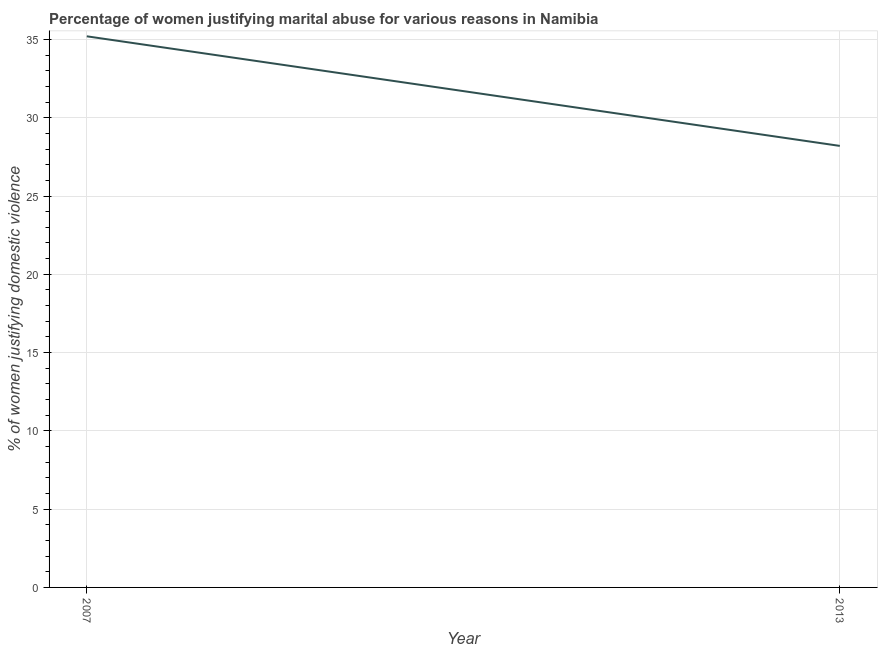What is the percentage of women justifying marital abuse in 2007?
Offer a very short reply. 35.2. Across all years, what is the maximum percentage of women justifying marital abuse?
Offer a very short reply. 35.2. Across all years, what is the minimum percentage of women justifying marital abuse?
Give a very brief answer. 28.2. In which year was the percentage of women justifying marital abuse maximum?
Provide a short and direct response. 2007. What is the sum of the percentage of women justifying marital abuse?
Your answer should be very brief. 63.4. What is the difference between the percentage of women justifying marital abuse in 2007 and 2013?
Make the answer very short. 7. What is the average percentage of women justifying marital abuse per year?
Provide a succinct answer. 31.7. What is the median percentage of women justifying marital abuse?
Your response must be concise. 31.7. In how many years, is the percentage of women justifying marital abuse greater than 19 %?
Provide a short and direct response. 2. What is the ratio of the percentage of women justifying marital abuse in 2007 to that in 2013?
Make the answer very short. 1.25. In how many years, is the percentage of women justifying marital abuse greater than the average percentage of women justifying marital abuse taken over all years?
Provide a succinct answer. 1. How many lines are there?
Your answer should be compact. 1. How many years are there in the graph?
Give a very brief answer. 2. What is the difference between two consecutive major ticks on the Y-axis?
Ensure brevity in your answer.  5. Does the graph contain any zero values?
Your response must be concise. No. What is the title of the graph?
Offer a very short reply. Percentage of women justifying marital abuse for various reasons in Namibia. What is the label or title of the X-axis?
Your answer should be very brief. Year. What is the label or title of the Y-axis?
Keep it short and to the point. % of women justifying domestic violence. What is the % of women justifying domestic violence of 2007?
Offer a very short reply. 35.2. What is the % of women justifying domestic violence of 2013?
Make the answer very short. 28.2. What is the ratio of the % of women justifying domestic violence in 2007 to that in 2013?
Provide a succinct answer. 1.25. 